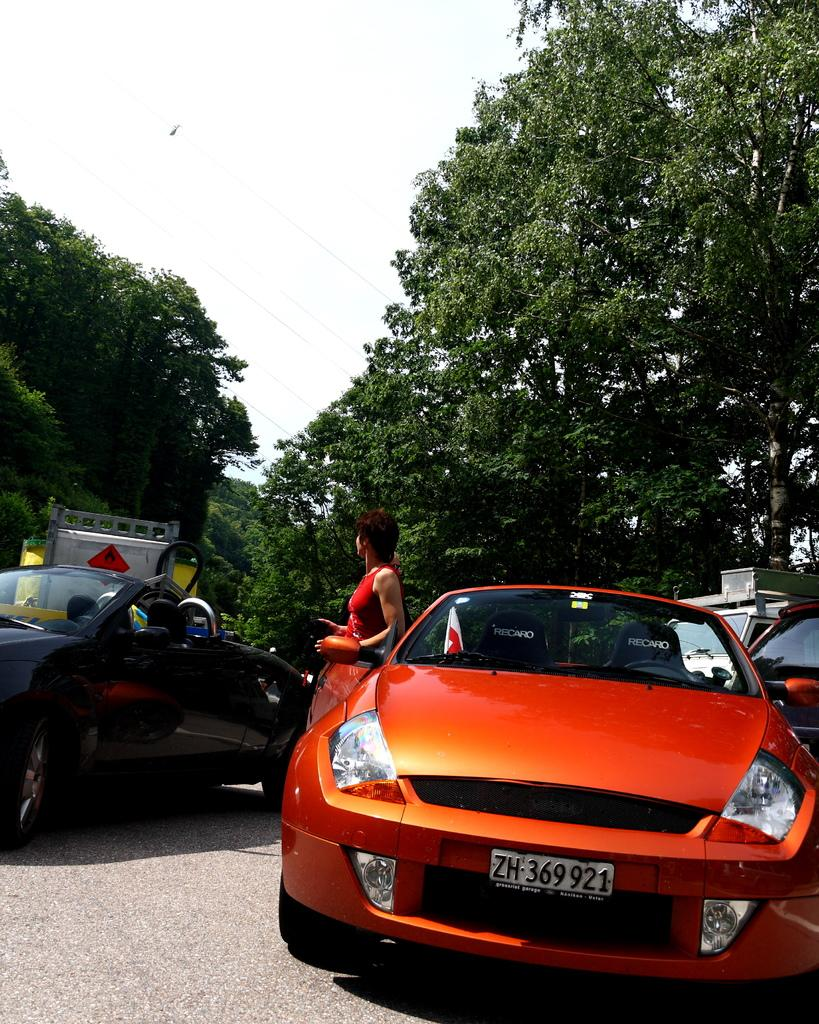Who is present in the image? There is a woman in the image. What can be seen on the road in the image? There are cars on the road in the image. What type of vegetation is visible in the background of the image? There are trees in the background of the image. What is visible in the sky in the image? The sky is visible in the background of the image. What type of drum can be seen in the woman's hand in the image? There is no drum present in the image; the woman's hands are not visible. 